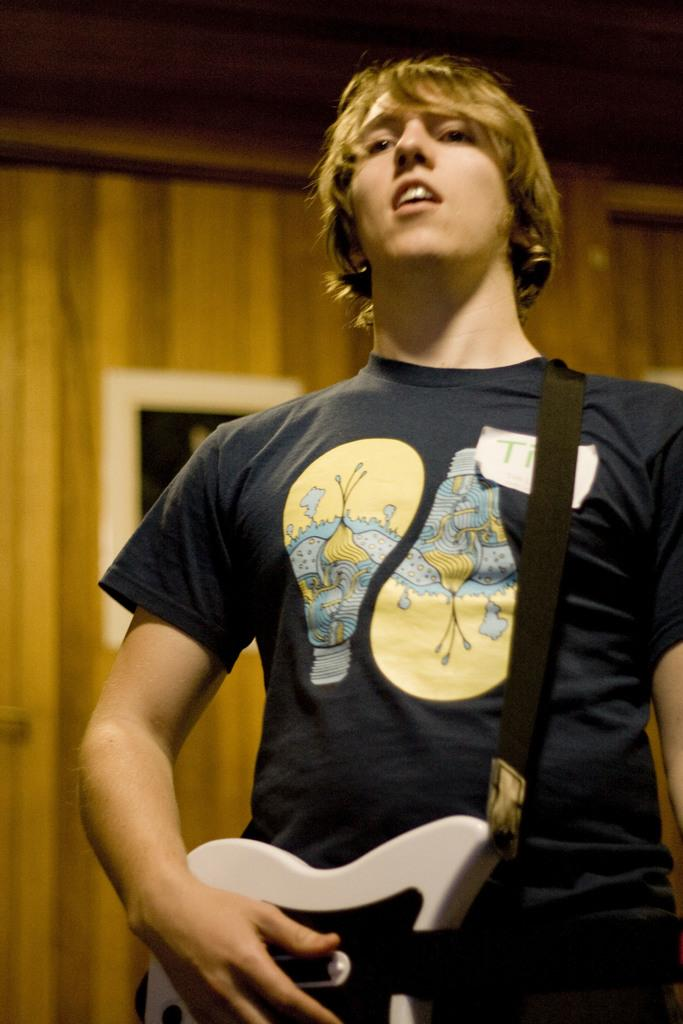What is the main subject of the image? The main subject of the image is a boy. What is the boy holding in the image? The boy is holding a music instrument. Can you describe the music instrument? The music instrument is white in color. What can be seen in the background of the image? There is a yellow color wall in the background of the image. Is there a crate being used as a stage for the boy to perform in the image? There is no crate present in the image, and the boy is not performing on a stage. 